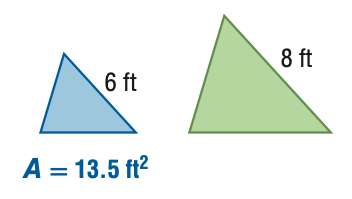Question: For the pair of similar figures, find the area of the green figure.
Choices:
A. 7.6
B. 10.1
C. 18
D. 24
Answer with the letter. Answer: D 